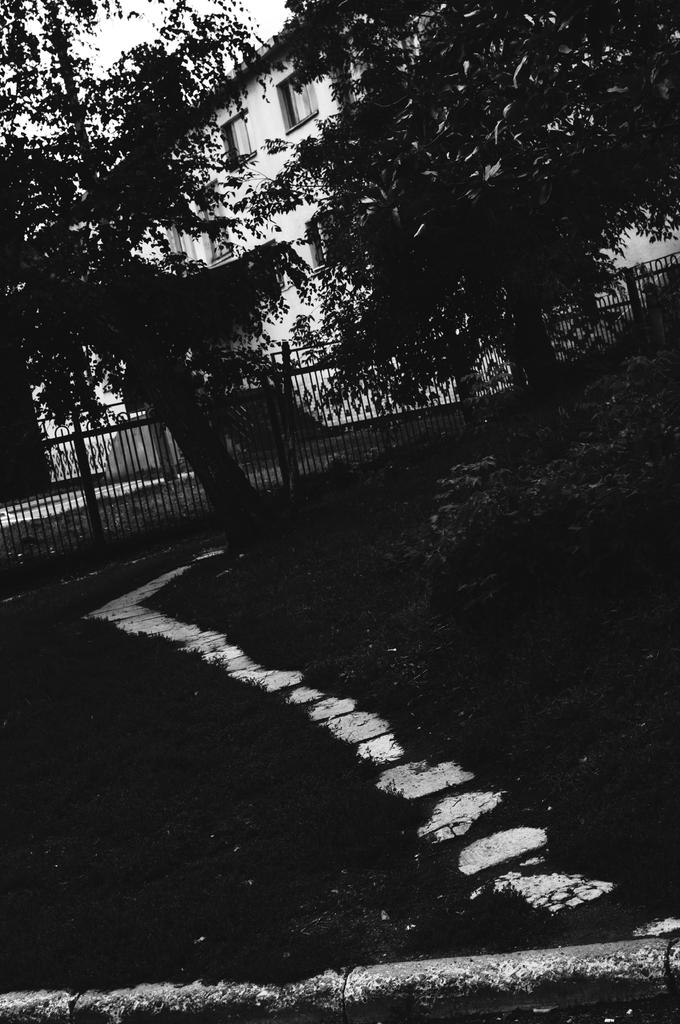What is the color scheme of the image? The image is black and white. What type of vegetation can be seen in the image? There is grass in the image. What kind of feature is present for walking or traversing? There is a path in the image. What structure is present to separate or enclose an area? There is a fence in the image. What type of natural elements are visible in the image? There are trees in the image. What type of man-made structure is present in the image? There is a building in the image. What architectural feature is present in the building? There are windows in the image. What part of the natural environment is visible in the image? The sky is visible in the image. What type of sack is being used to carry the disease in the image? There is no sack or disease present in the image. 